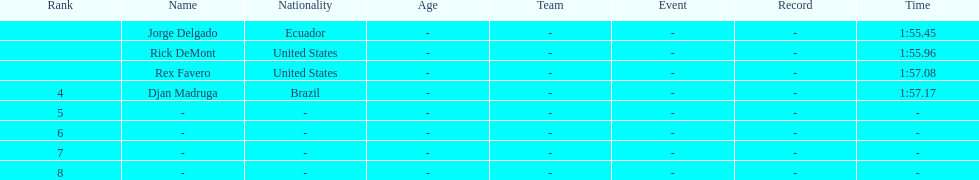Who finished with the top time? Jorge Delgado. 